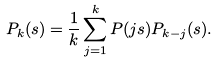Convert formula to latex. <formula><loc_0><loc_0><loc_500><loc_500>P _ { k } ( s ) = \frac { 1 } { k } \sum _ { j = 1 } ^ { k } P ( j s ) P _ { k - j } ( s ) .</formula> 